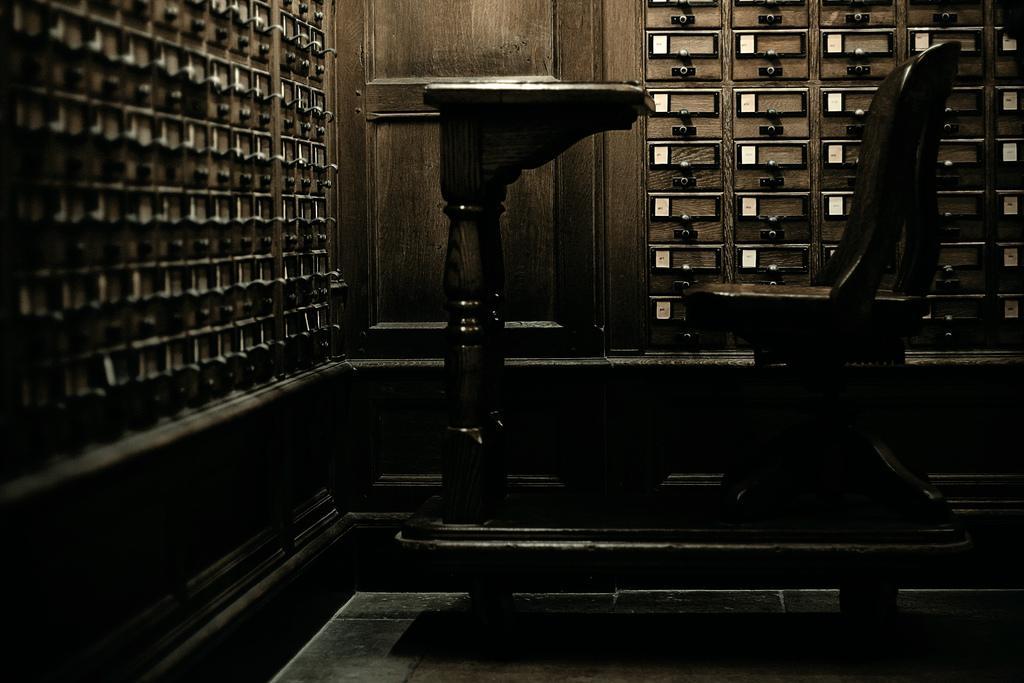Please provide a concise description of this image. In this image I can see number of drawers and a chair over here. I can also see this image is little bit in dark from here. 